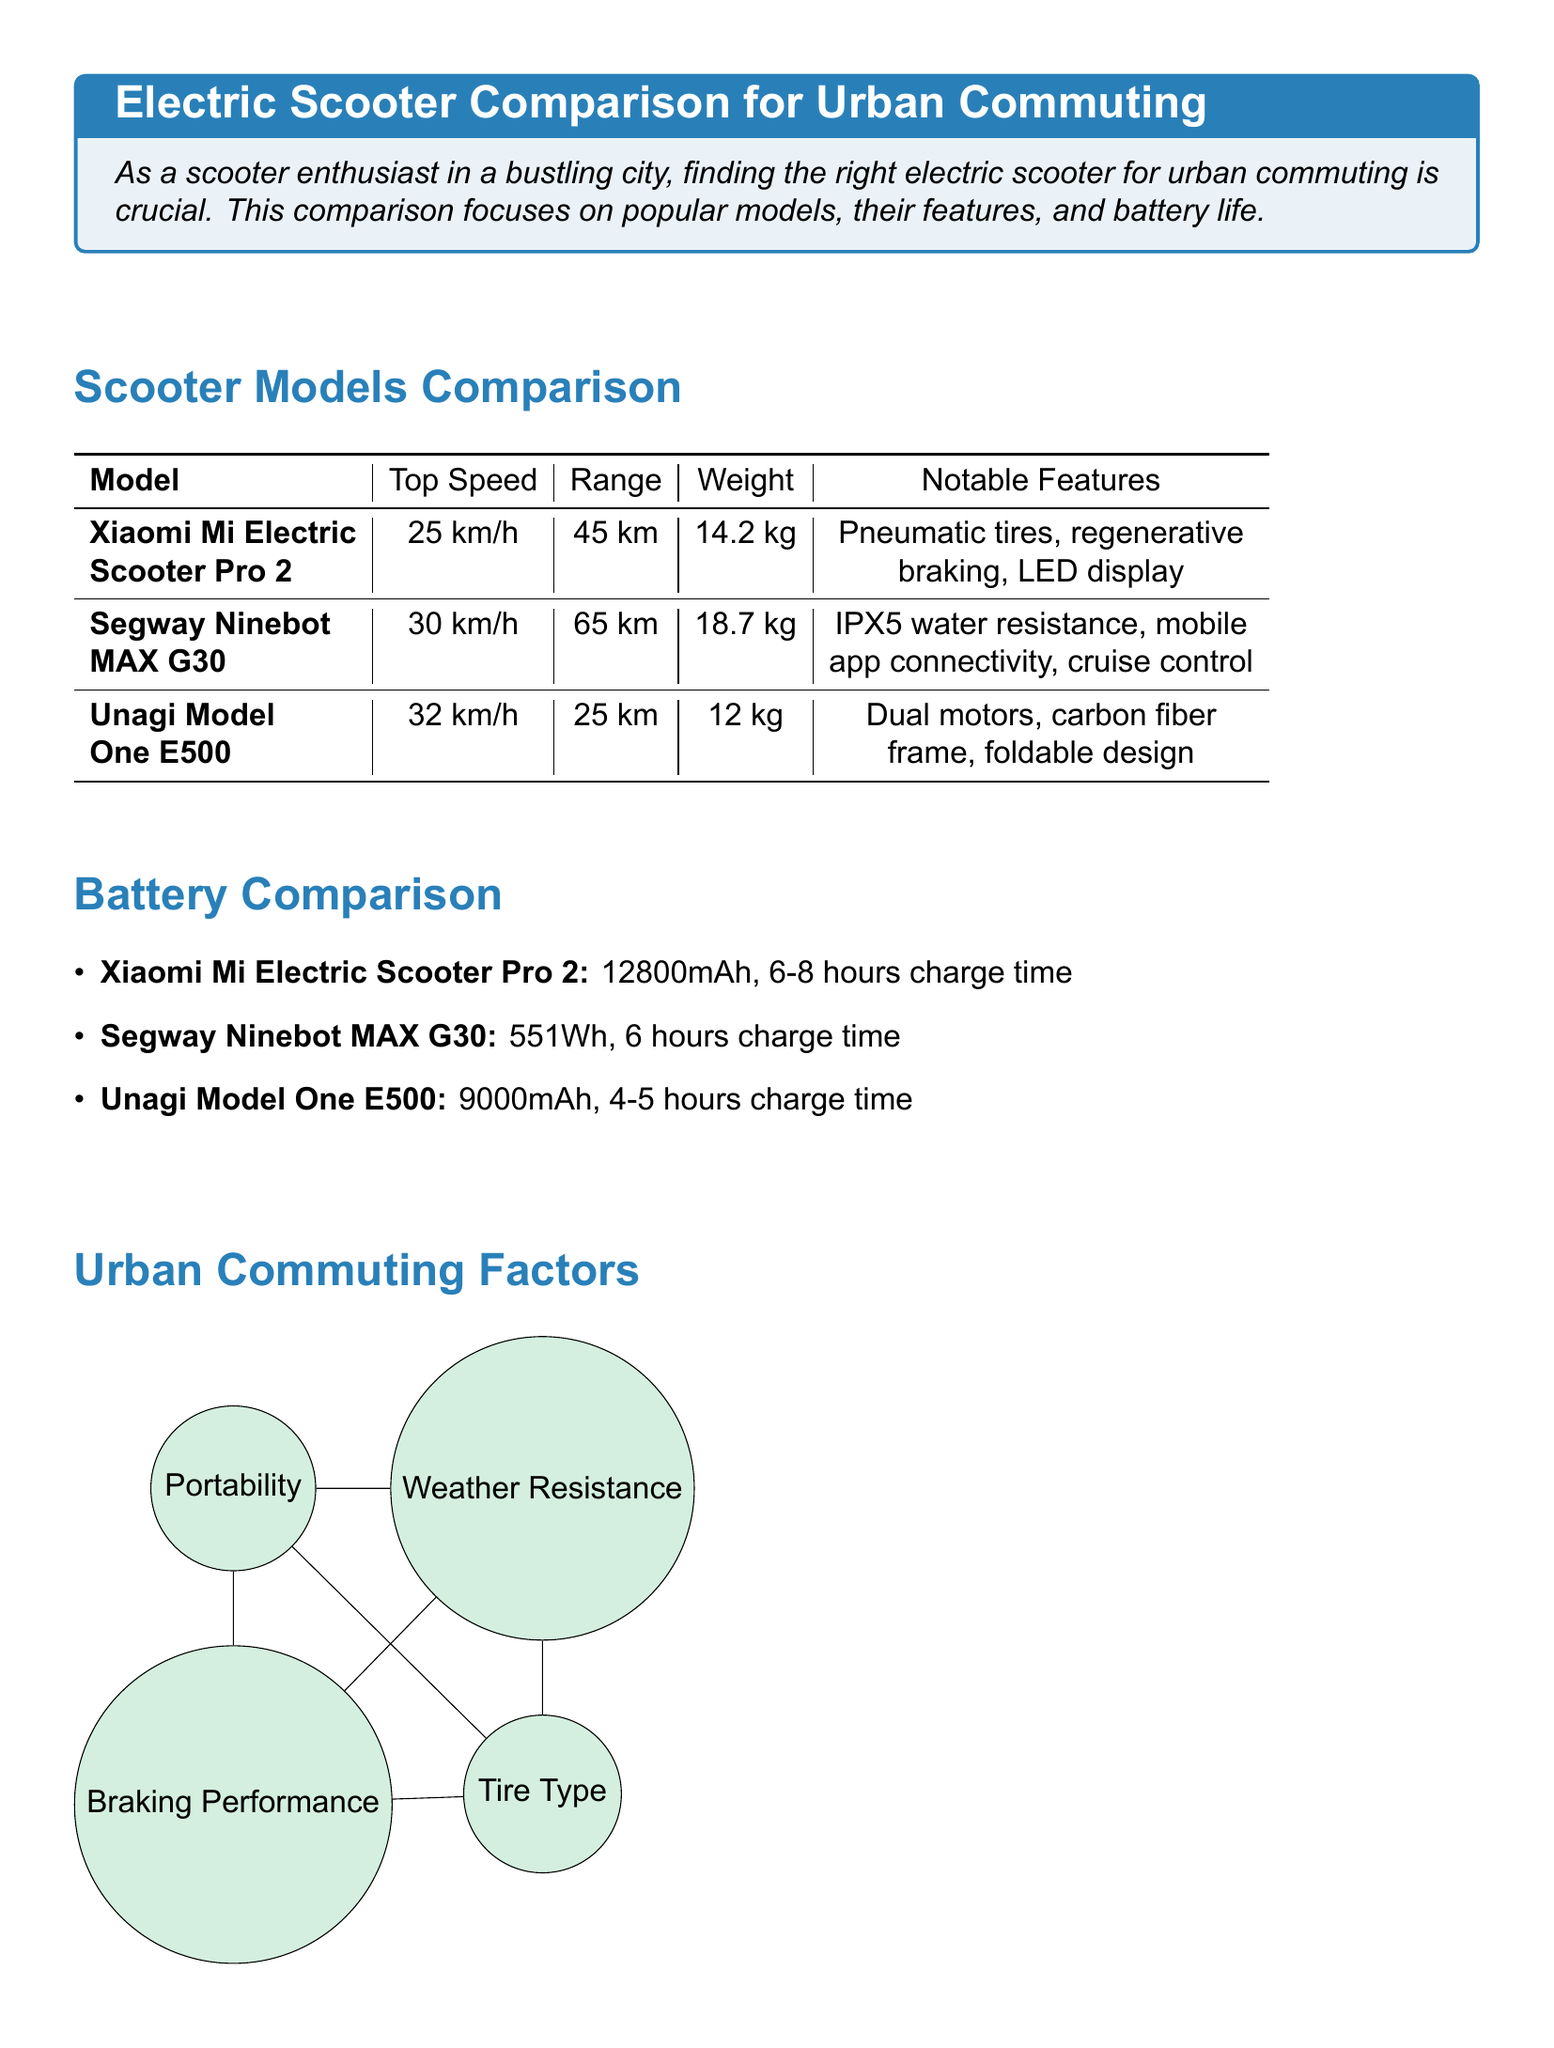What is the title of the document? The title is provided in the heading of the document, which is "Electric Scooter Comparison for Urban Commuting."
Answer: Electric Scooter Comparison for Urban Commuting What is the top speed of the Segway Ninebot MAX G30? The top speed can be found in the scooter models comparison table, specifically for Segway Ninebot MAX G30, which is 30 km/h.
Answer: 30 km/h What is the weight of the Unagi Model One E500? The weight information is specified in the models section, indicating that the Unagi Model One E500 weighs 12 kg.
Answer: 12 kg What is the battery capacity of the Xiaomi Mi Electric Scooter Pro 2? The battery capacity is listed in the battery comparison section, showing that it has a capacity of 12800mAh.
Answer: 12800mAh Which model has the longest range? By analyzing the range information in the models comparison, Segway Ninebot MAX G30 has the longest range of 65 km.
Answer: 65 km Why is braking performance important for urban commuting? Braking performance is highlighted as a crucial urban commuting factor due to the busy streets in a city environment.
Answer: Busy streets What additional features does the Segway Ninebot MAX G30 offer? The notable features for this model can be found in the scooter models comparison, including IPX5 water resistance, mobile app connectivity, and cruise control.
Answer: IPX5 water resistance, mobile app connectivity, cruise control How long does it take to charge the Unagi Model One E500? The charging time for this model is specifically indicated in the battery comparison section as 4-5 hours.
Answer: 4-5 hours What three factors should be prioritized when choosing an electric scooter? The conclusion emphasizes specific needs, suggesting to prioritize range, portability, and durability.
Answer: Range, portability, durability 